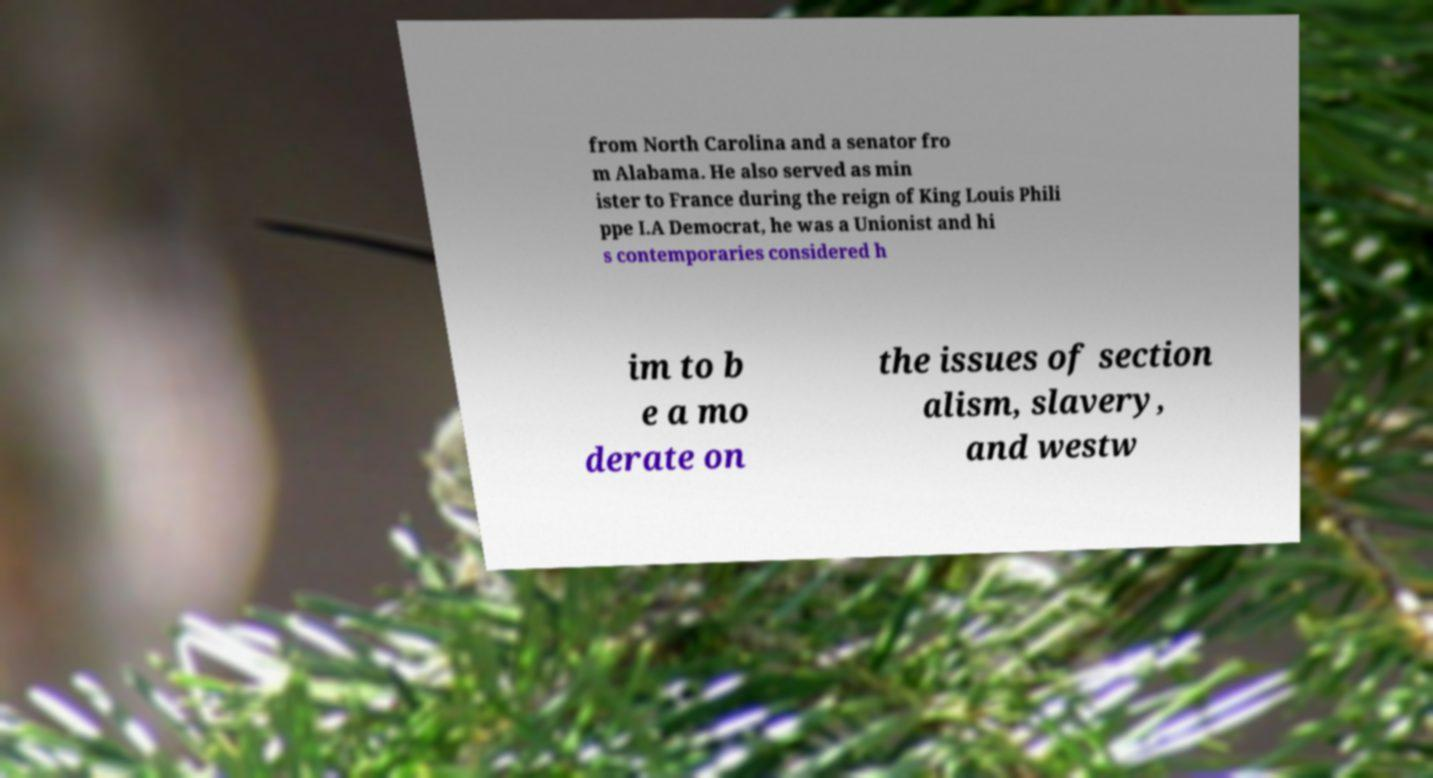Can you accurately transcribe the text from the provided image for me? from North Carolina and a senator fro m Alabama. He also served as min ister to France during the reign of King Louis Phili ppe I.A Democrat, he was a Unionist and hi s contemporaries considered h im to b e a mo derate on the issues of section alism, slavery, and westw 